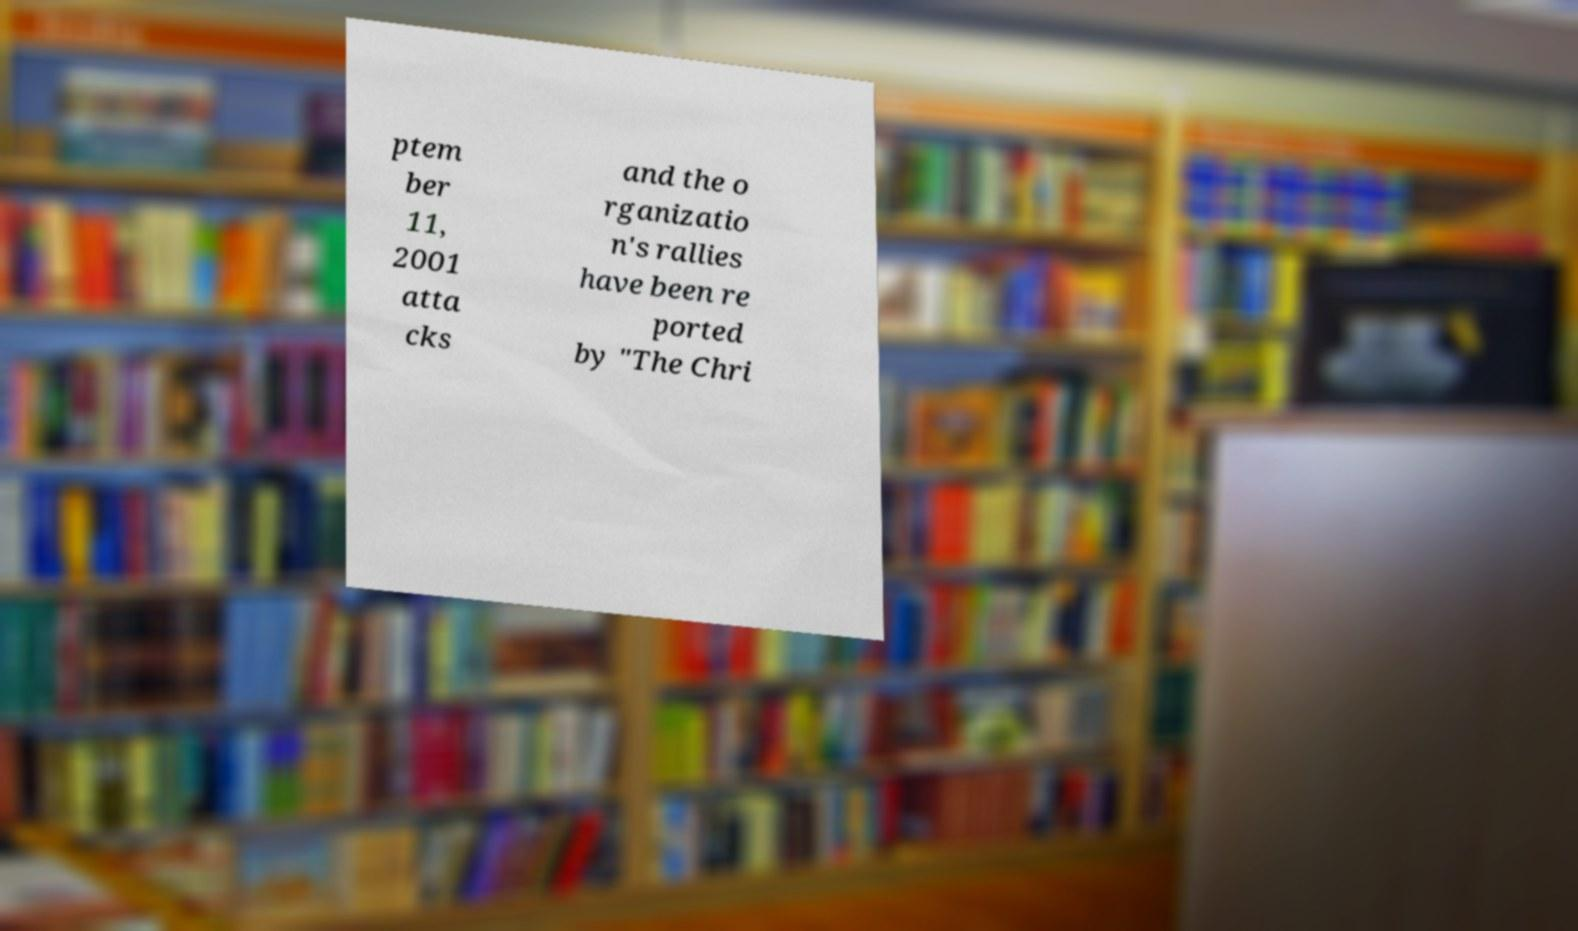What messages or text are displayed in this image? I need them in a readable, typed format. ptem ber 11, 2001 atta cks and the o rganizatio n's rallies have been re ported by "The Chri 